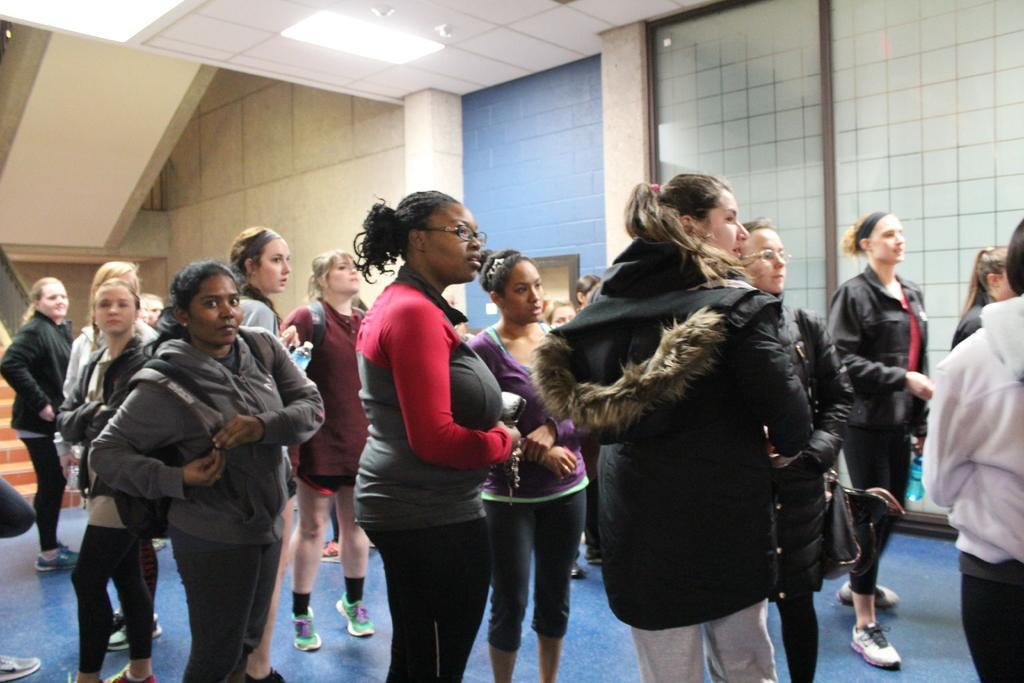What is the main subject of the image? The main subject of the image is a group of people. Can you describe the composition of the group? There are women in the group. What can be seen in the background of the image? There is a light and walls in the background of the image. What type of cracker is being used to create the wax sculpture in the image? There is no cracker or wax sculpture present in the image. What architectural feature can be seen in the image? The image does not show any specific architectural features like an arch. 